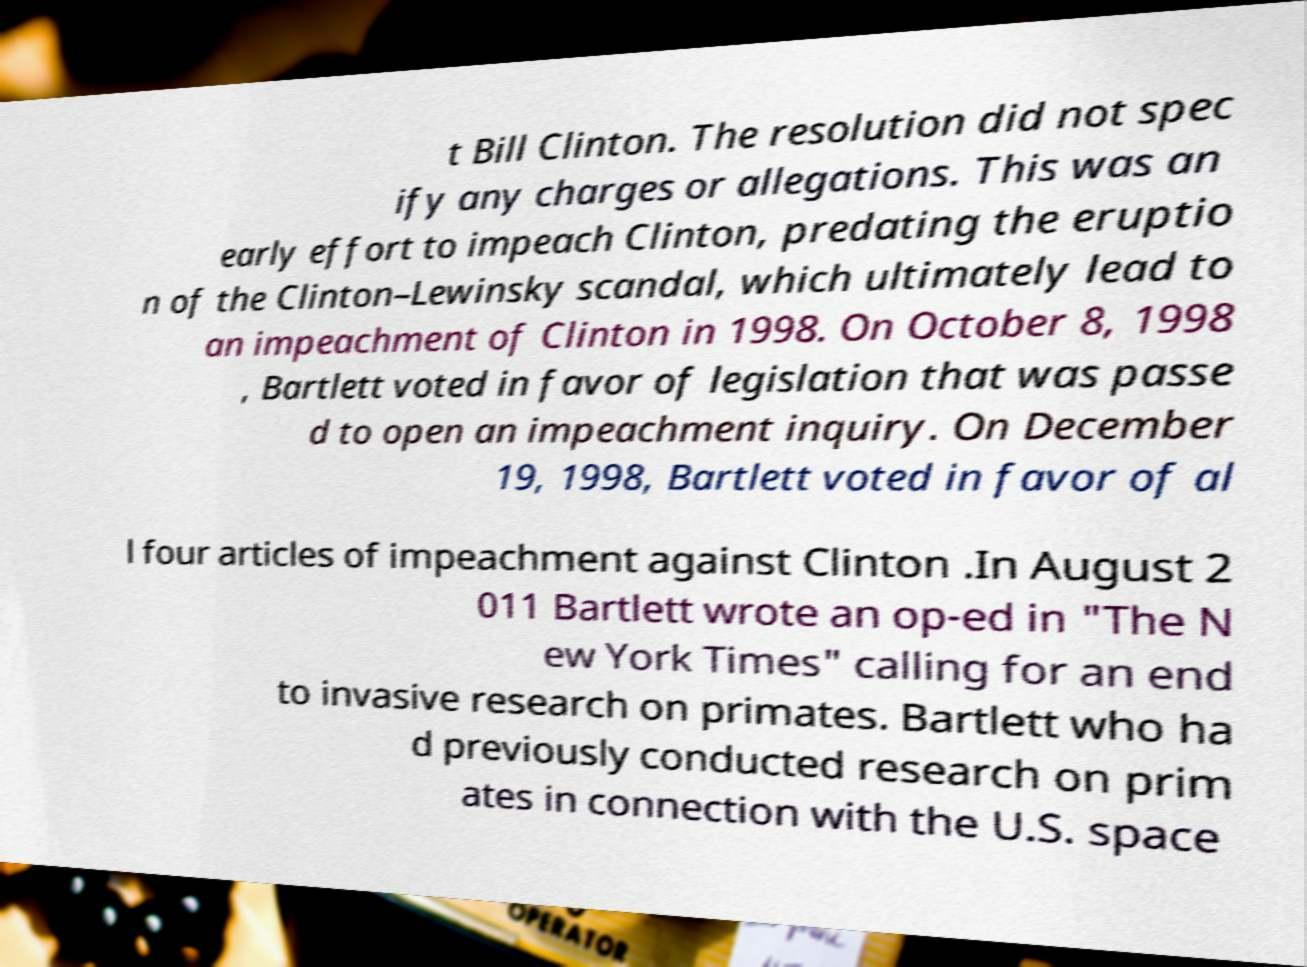I need the written content from this picture converted into text. Can you do that? t Bill Clinton. The resolution did not spec ify any charges or allegations. This was an early effort to impeach Clinton, predating the eruptio n of the Clinton–Lewinsky scandal, which ultimately lead to an impeachment of Clinton in 1998. On October 8, 1998 , Bartlett voted in favor of legislation that was passe d to open an impeachment inquiry. On December 19, 1998, Bartlett voted in favor of al l four articles of impeachment against Clinton .In August 2 011 Bartlett wrote an op-ed in "The N ew York Times" calling for an end to invasive research on primates. Bartlett who ha d previously conducted research on prim ates in connection with the U.S. space 